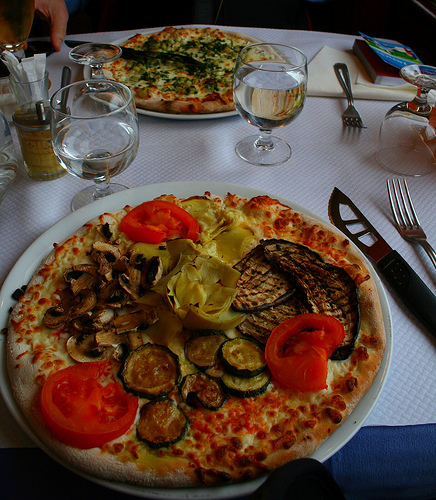<image>
Is there a knife to the right of the fork? No. The knife is not to the right of the fork. The horizontal positioning shows a different relationship. 